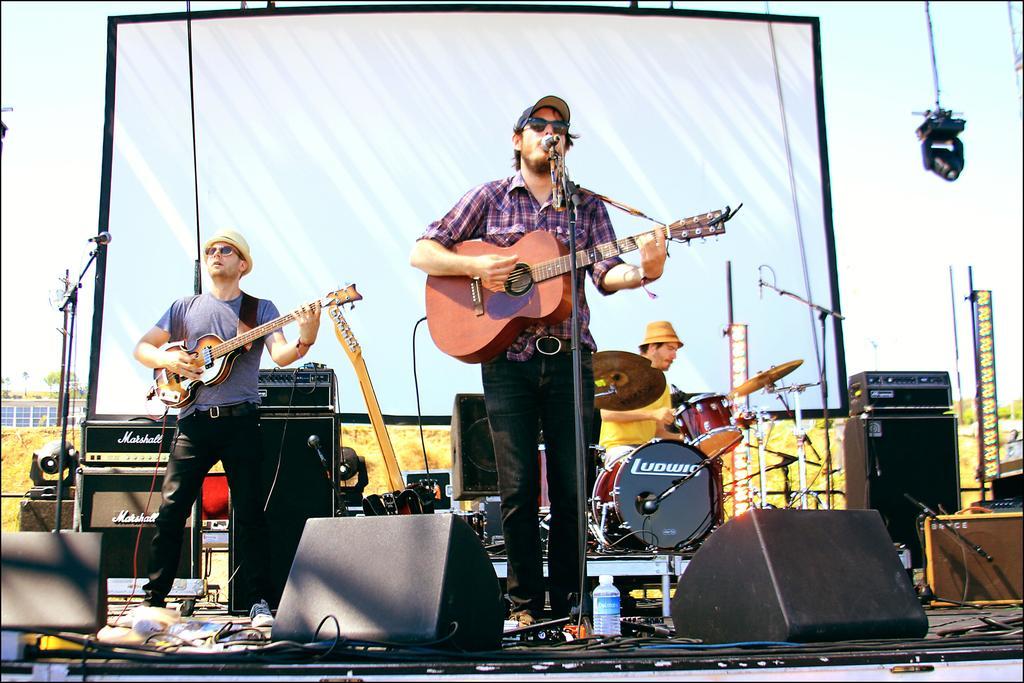Could you give a brief overview of what you see in this image? There are two persons playing guitar. These are the mikes. Here we can see a man who is playing drums. These are some musical instruments. On the background there is a screen and this is sky. 